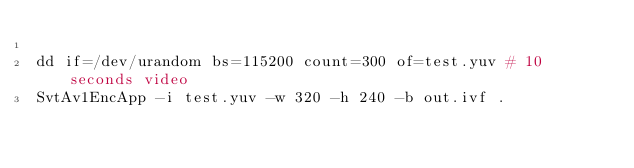<code> <loc_0><loc_0><loc_500><loc_500><_Bash_>
dd if=/dev/urandom bs=115200 count=300 of=test.yuv # 10 seconds video
SvtAv1EncApp -i test.yuv -w 320 -h 240 -b out.ivf .
</code> 